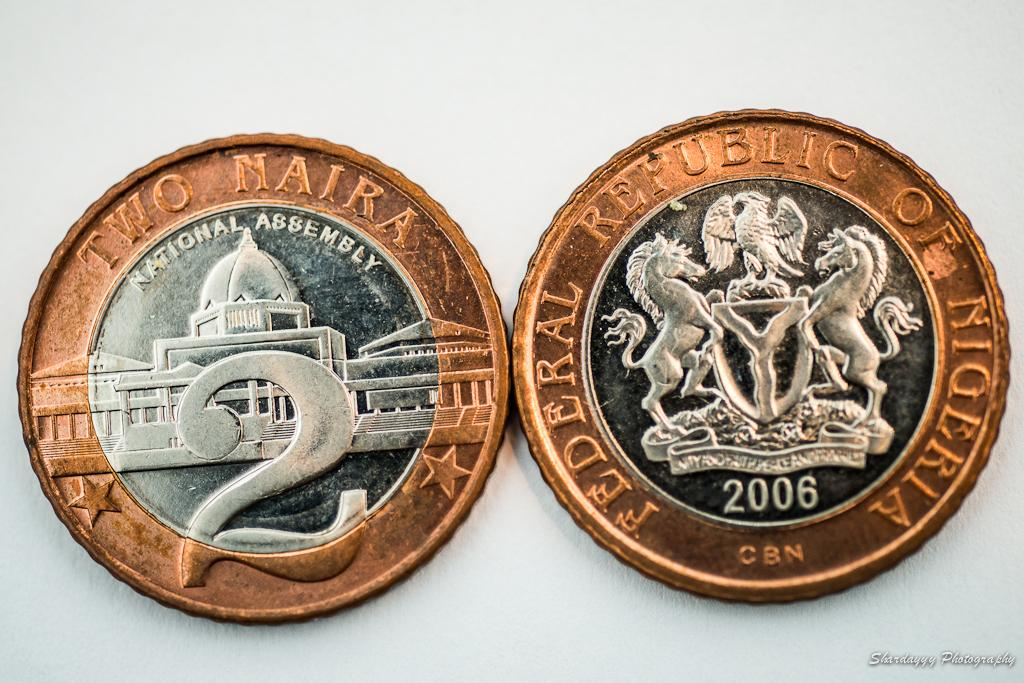<image>
Create a compact narrative representing the image presented. Two coins with the one on the left mentioning the national assembly. 